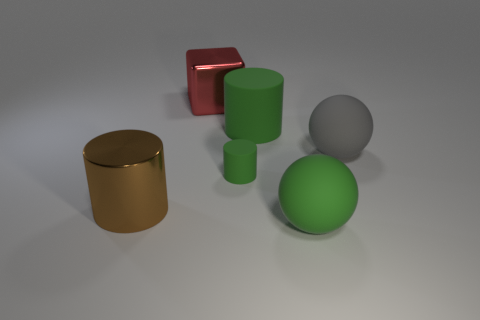Subtract all purple spheres. Subtract all purple blocks. How many spheres are left? 2 Add 1 large green things. How many objects exist? 7 Subtract all spheres. How many objects are left? 4 Add 4 large cylinders. How many large cylinders are left? 6 Add 3 tiny cylinders. How many tiny cylinders exist? 4 Subtract 0 yellow spheres. How many objects are left? 6 Subtract all big brown things. Subtract all big brown metal cylinders. How many objects are left? 4 